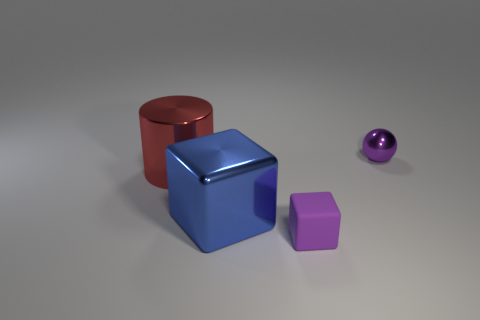Add 4 tiny red matte cylinders. How many objects exist? 8 Subtract all spheres. How many objects are left? 3 Subtract 0 gray cylinders. How many objects are left? 4 Subtract all red metallic objects. Subtract all balls. How many objects are left? 2 Add 2 big cylinders. How many big cylinders are left? 3 Add 2 rubber cubes. How many rubber cubes exist? 3 